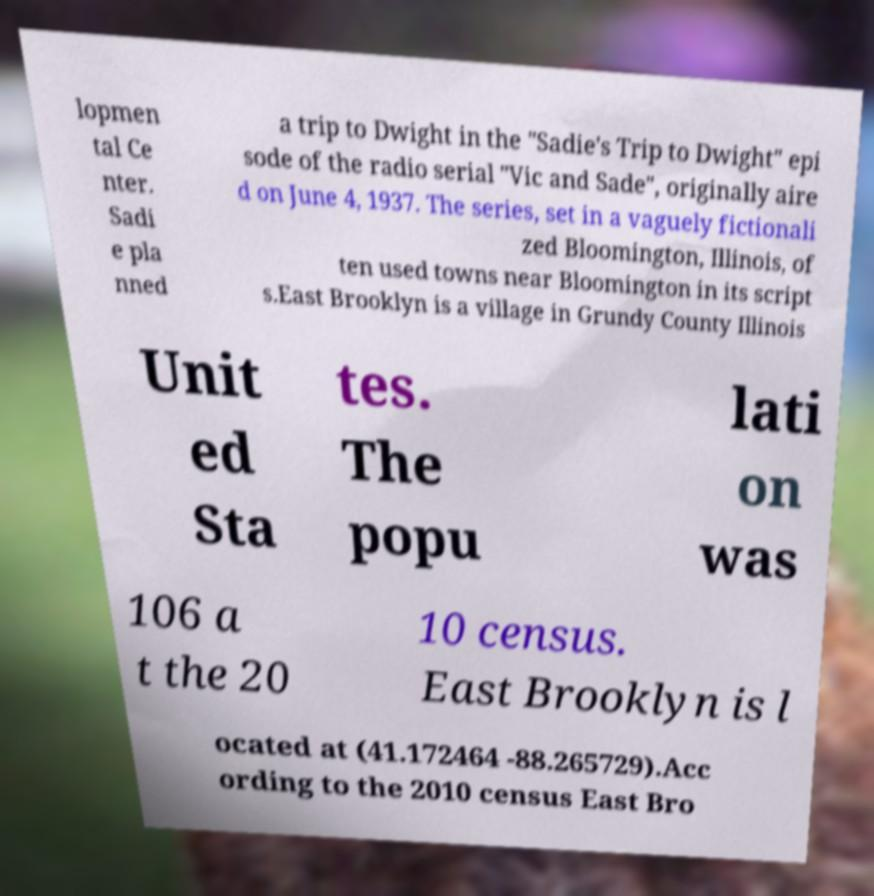There's text embedded in this image that I need extracted. Can you transcribe it verbatim? lopmen tal Ce nter. Sadi e pla nned a trip to Dwight in the "Sadie's Trip to Dwight" epi sode of the radio serial "Vic and Sade", originally aire d on June 4, 1937. The series, set in a vaguely fictionali zed Bloomington, Illinois, of ten used towns near Bloomington in its script s.East Brooklyn is a village in Grundy County Illinois Unit ed Sta tes. The popu lati on was 106 a t the 20 10 census. East Brooklyn is l ocated at (41.172464 -88.265729).Acc ording to the 2010 census East Bro 